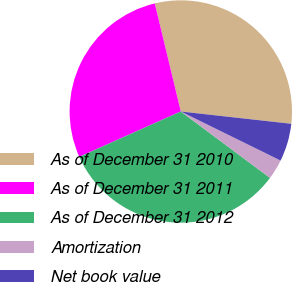Convert chart. <chart><loc_0><loc_0><loc_500><loc_500><pie_chart><fcel>As of December 31 2010<fcel>As of December 31 2011<fcel>As of December 31 2012<fcel>Amortization<fcel>Net book value<nl><fcel>30.52%<fcel>27.92%<fcel>33.12%<fcel>2.91%<fcel>5.51%<nl></chart> 